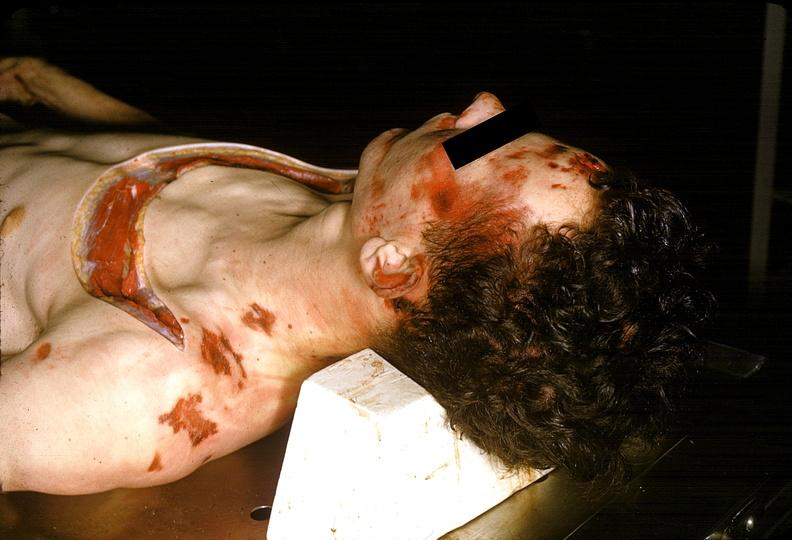does quite good liver show severe trauma, contusion, lacerations, abrasions?
Answer the question using a single word or phrase. No 